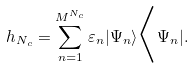<formula> <loc_0><loc_0><loc_500><loc_500>h _ { N _ { c } } = \sum _ { n = 1 } ^ { M ^ { N _ { c } } } \varepsilon _ { n } | \Psi _ { n } \rangle \Big { < } \Psi _ { n } | .</formula> 